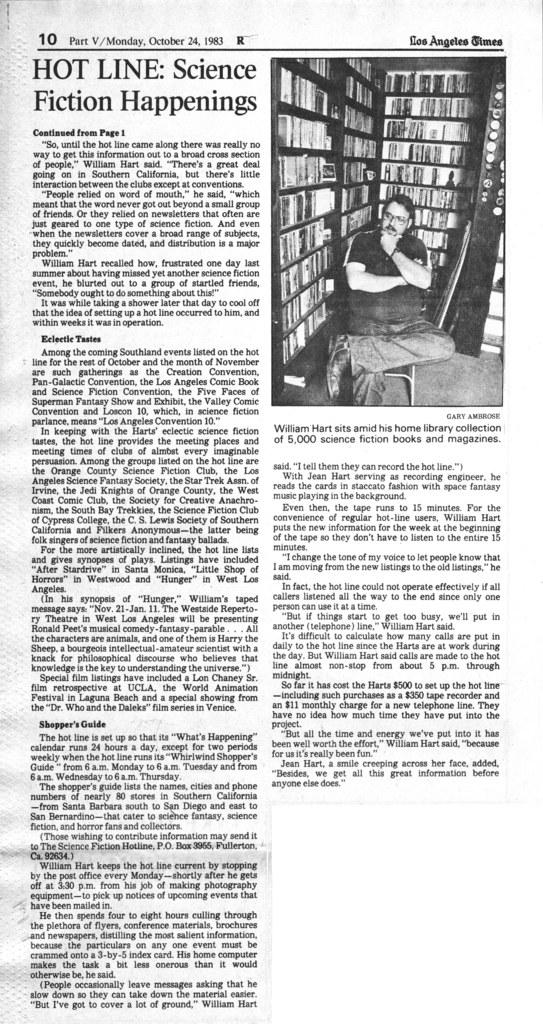What type of publication is visible in the image? There is a newspaper in the image. What are the two main components of the newspaper? There is an article and an image in the image, both part of the newspaper. What type of canvas is depicted in the image? There is no canvas present in the image; it features an article and an image from a newspaper. 